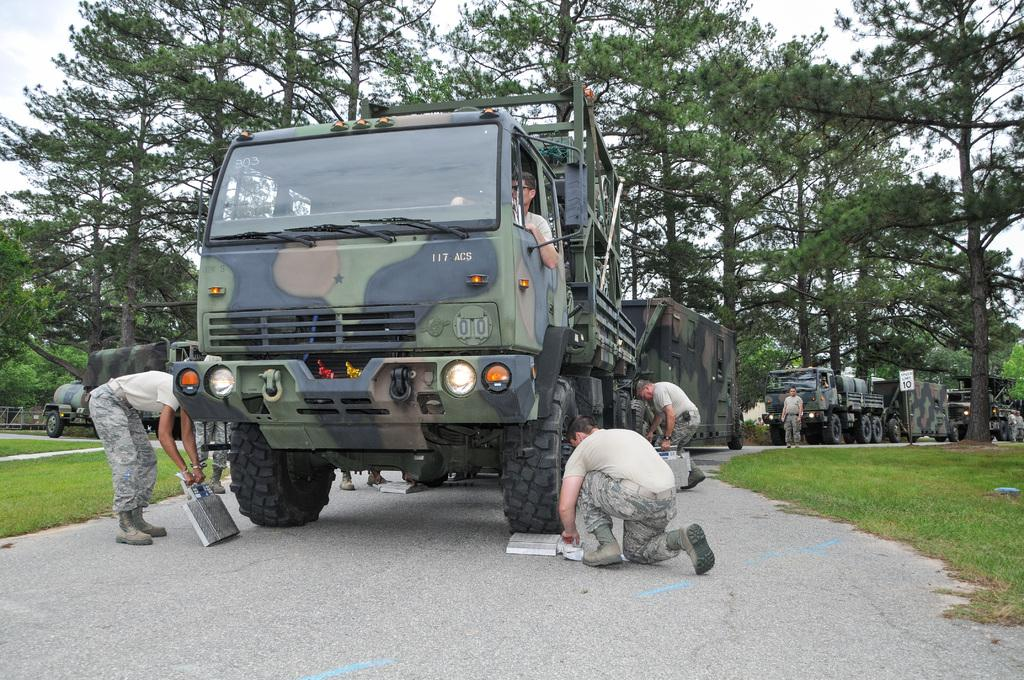What is the main subject of the image? The main subject of the image is many trucks on a road. Are there any people present in the image? Yes, there is a group of persons standing in the image. What type of natural environment is visible in the image? There are trees and grass visible in the image. What is visible in the background of the image? There is a sky visible in the image. What type of chess game is being played by the trees in the image? There is no chess game being played in the image; it features trucks on a road, a group of persons, trees, grass, and a sky. What color is the bag that the grass is holding in the image? There is no bag present in the image, as it features trucks on a road, a group of persons, trees, grass, and a sky. 